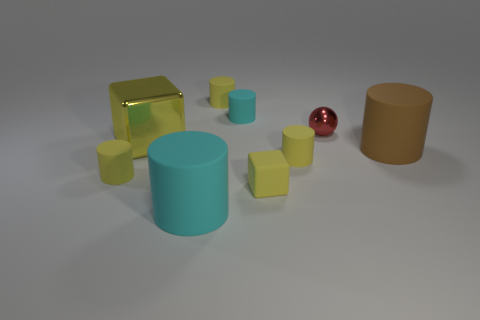Can you tell which objects are closest to the viewpoint? The closest objects to the viewpoint are the small yellow cylinders in the foreground, followed by the bigger, central cyan cylinder. 